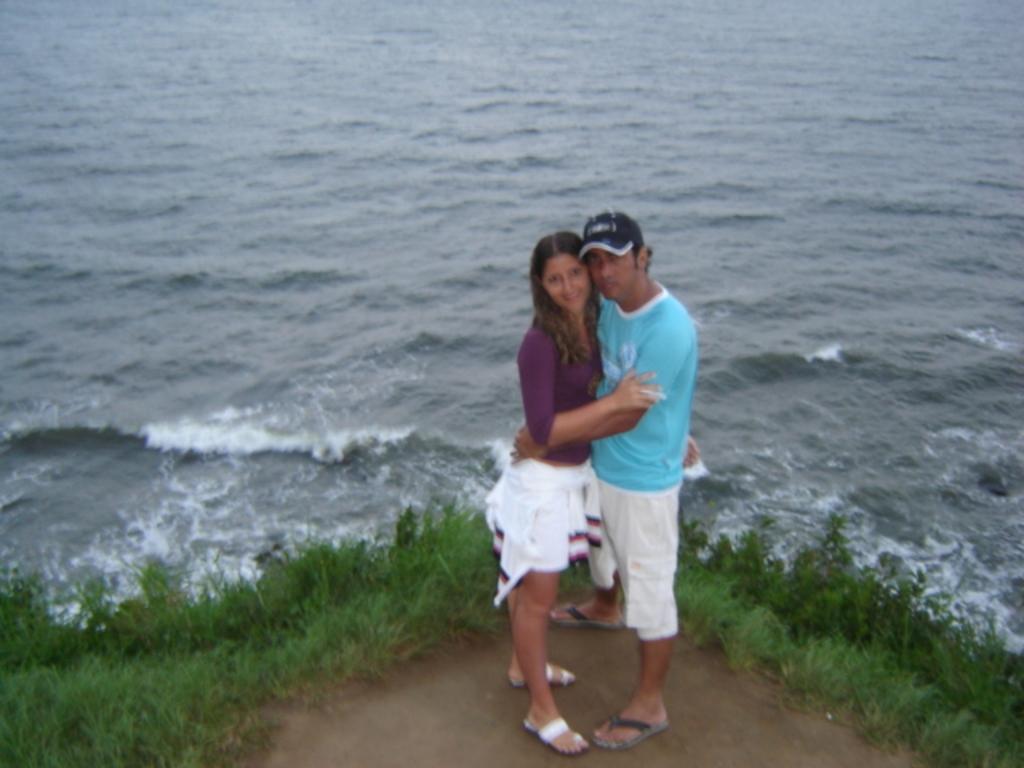Please provide a concise description of this image. In this image I can see two persons standing. The person at right wearing blue shirt, white pant and the person at left wearing purple color shirt and white color short. Background I can see grass in green color and water. 